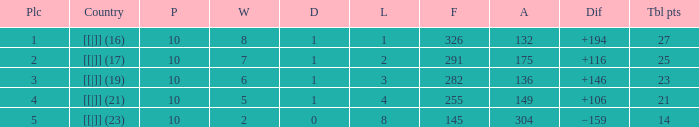 How many table points are listed for the deficit is +194?  1.0. 